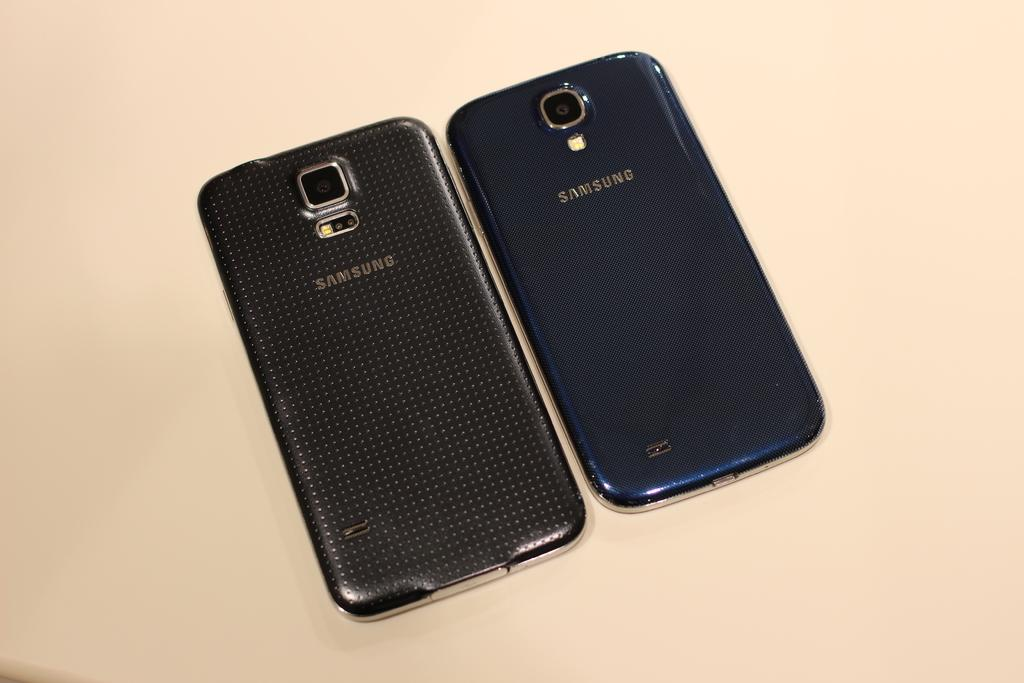<image>
Give a short and clear explanation of the subsequent image. the back view of two samsung cell phones 